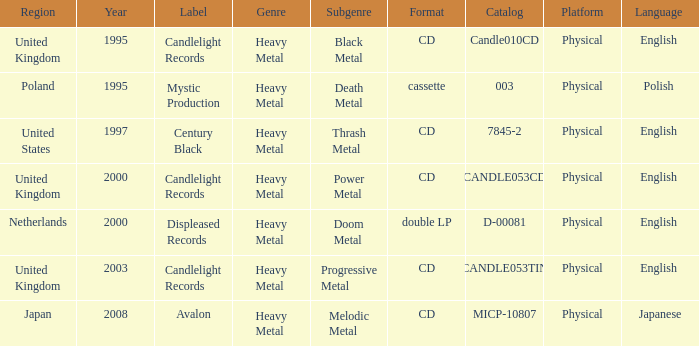What is Candlelight Records format? CD, CD, CD. 